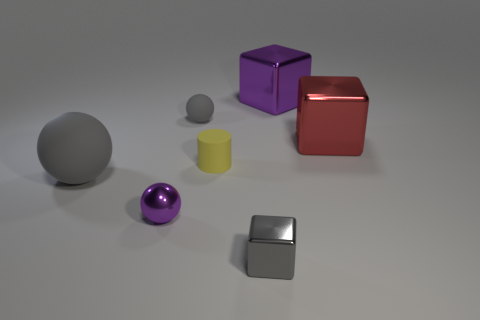Are the gray ball on the left side of the shiny sphere and the object in front of the metallic ball made of the same material?
Your answer should be very brief. No. Is the size of the sphere that is behind the yellow cylinder the same as the tiny gray shiny cube?
Offer a terse response. Yes. Do the tiny metal block and the sphere that is to the left of the tiny purple sphere have the same color?
Provide a short and direct response. Yes. There is a tiny matte thing that is the same color as the large ball; what is its shape?
Make the answer very short. Sphere. What is the shape of the tiny gray matte object?
Keep it short and to the point. Sphere. Is the color of the tiny shiny block the same as the large rubber ball?
Provide a succinct answer. Yes. How many objects are either things that are in front of the small cylinder or big cyan matte cubes?
Offer a terse response. 3. What is the size of the gray thing that is made of the same material as the large sphere?
Your answer should be very brief. Small. Is the number of small gray objects that are in front of the small yellow cylinder greater than the number of big brown objects?
Provide a succinct answer. Yes. Is the shape of the red metallic object the same as the purple metal thing behind the red shiny thing?
Your answer should be compact. Yes. 